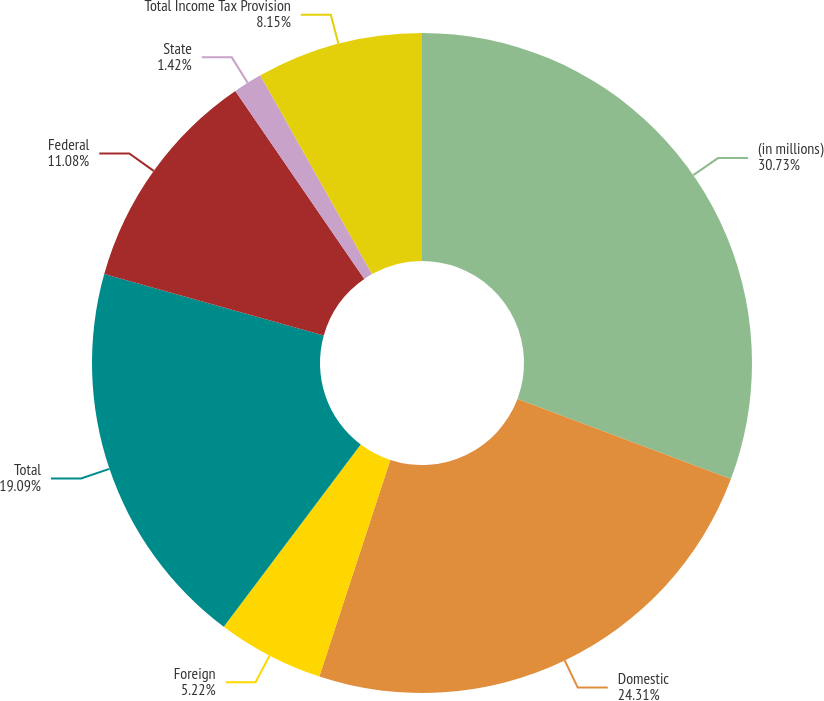<chart> <loc_0><loc_0><loc_500><loc_500><pie_chart><fcel>(in millions)<fcel>Domestic<fcel>Foreign<fcel>Total<fcel>Federal<fcel>State<fcel>Total Income Tax Provision<nl><fcel>30.72%<fcel>24.31%<fcel>5.22%<fcel>19.09%<fcel>11.08%<fcel>1.42%<fcel>8.15%<nl></chart> 